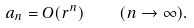<formula> <loc_0><loc_0><loc_500><loc_500>a _ { n } = O ( r ^ { n } ) \quad ( n \to \infty ) .</formula> 